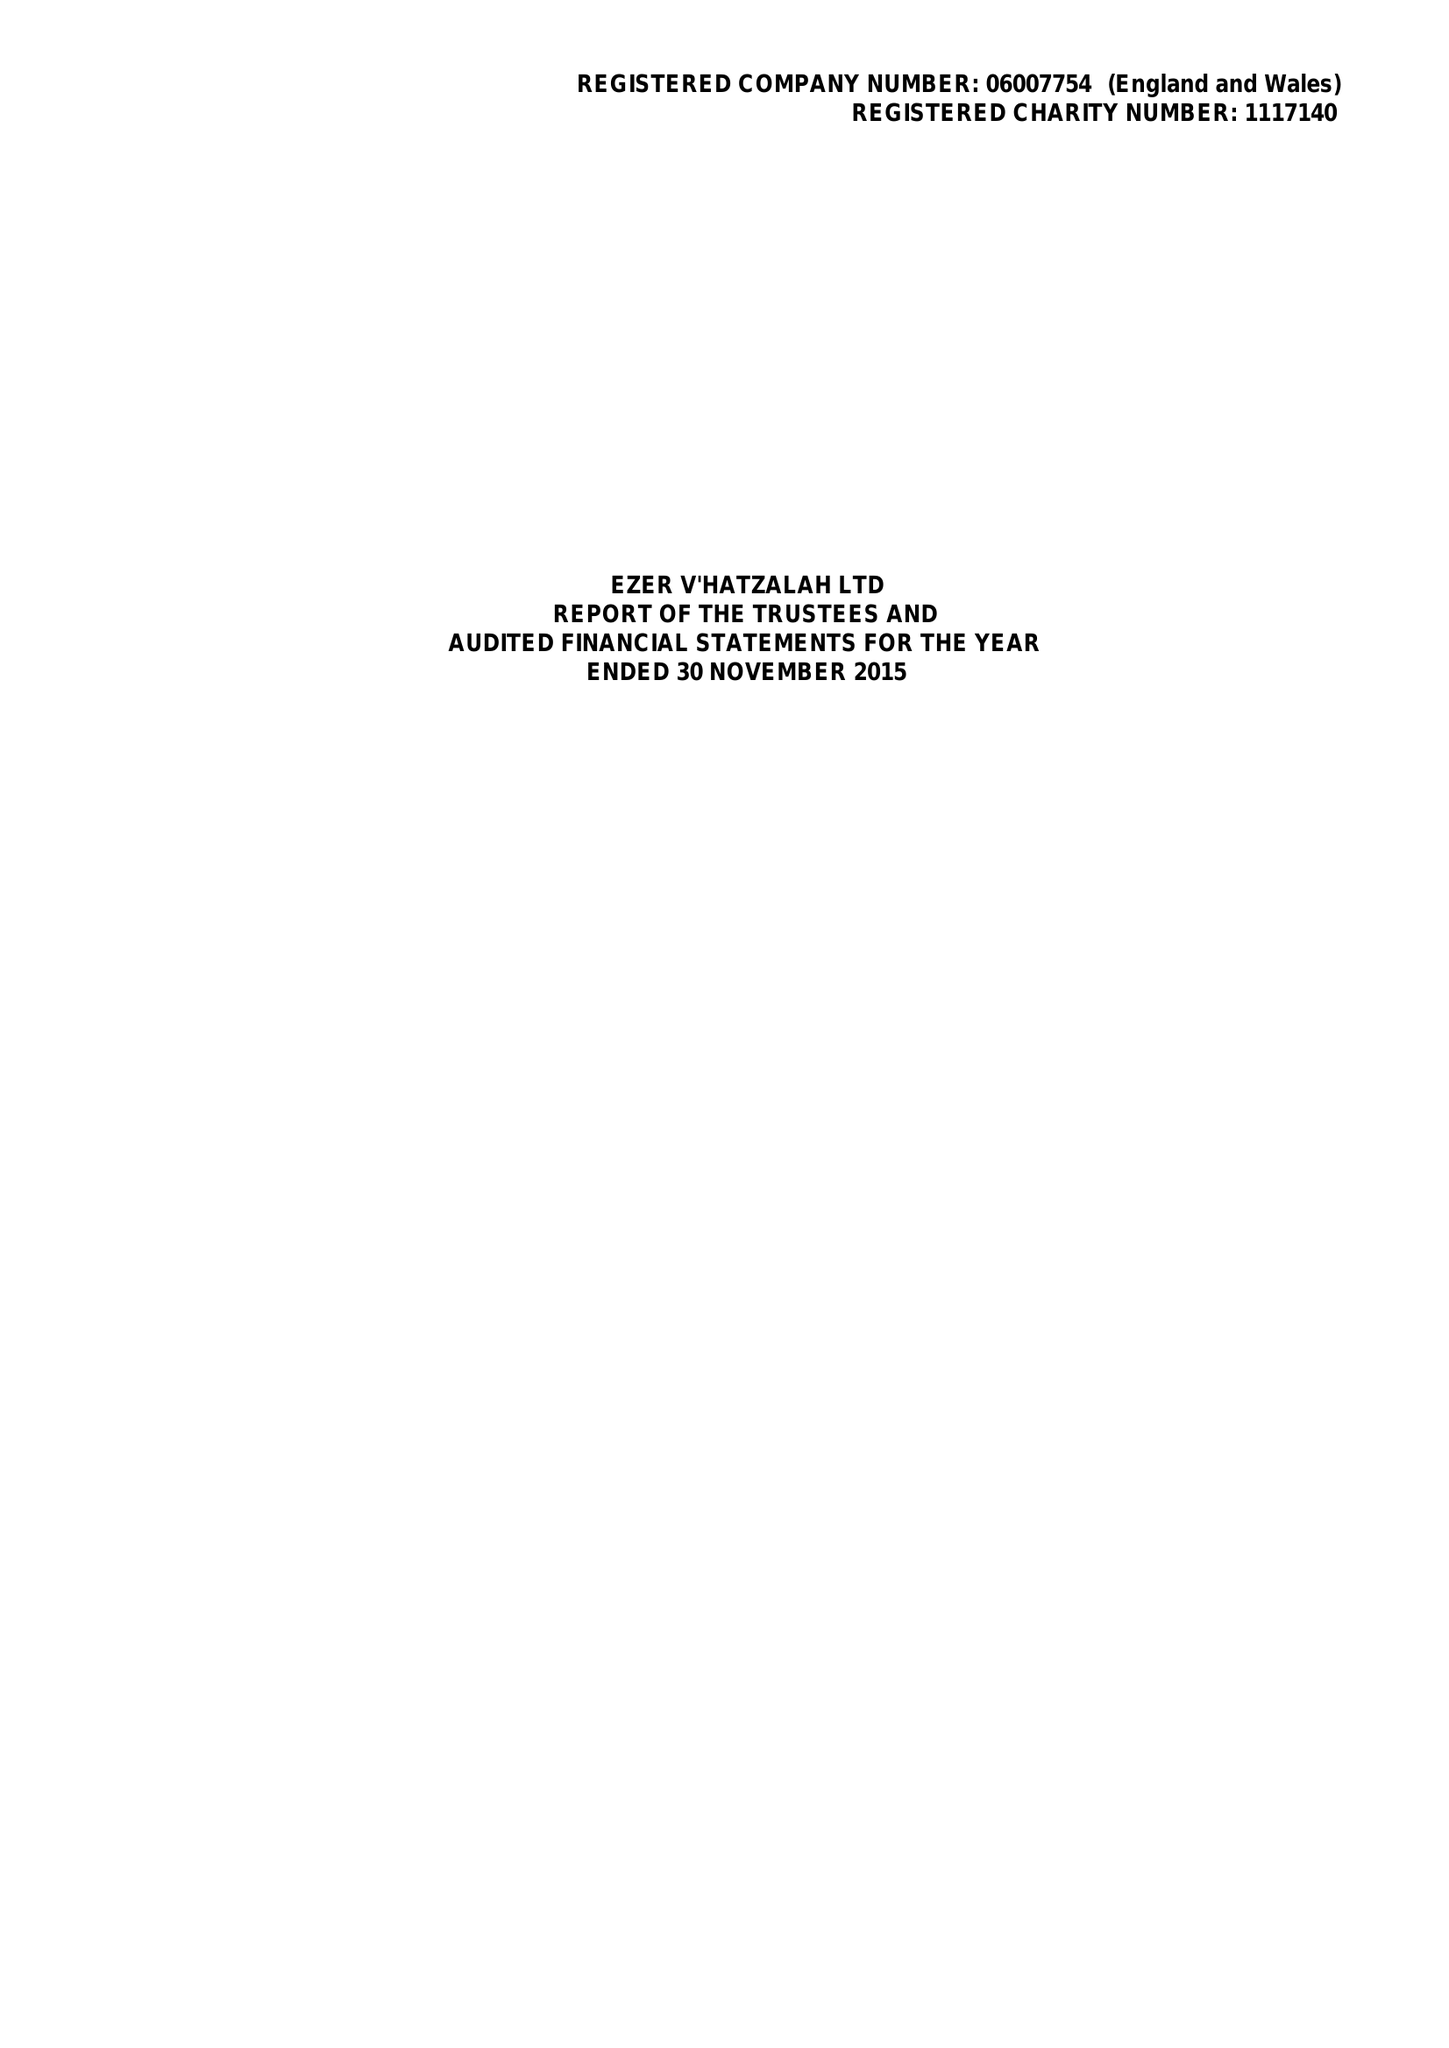What is the value for the charity_name?
Answer the question using a single word or phrase. Ezer V' Hatzalah Ltd. 